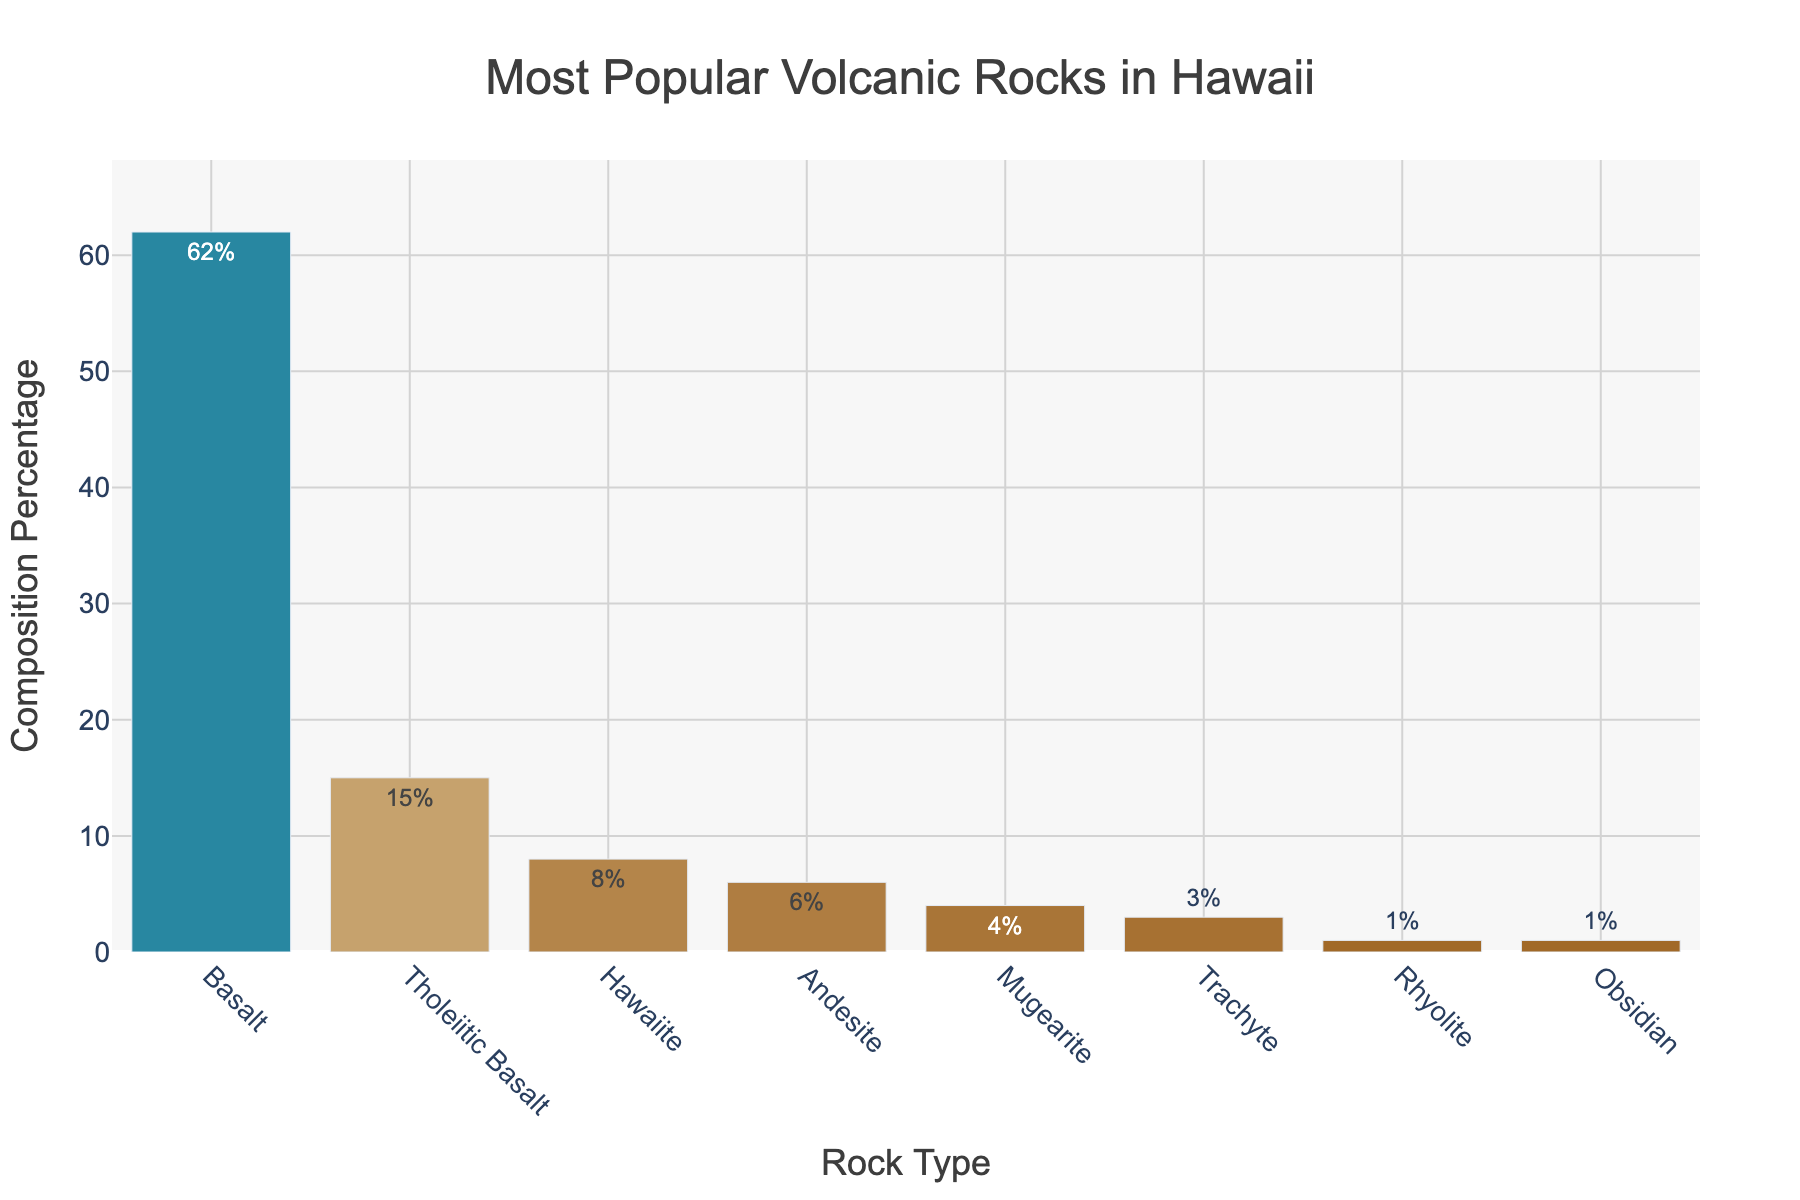Which volcanic rock type has the highest composition percentage? The rock type with the highest composition percentage has the tallest bar in the chart. Basalt has the tallest bar indicating it has the highest composition percentage.
Answer: Basalt What's the combined composition percentage of Trachyte, Rhyolite, and Obsidian? Add the composition percentages of Trachyte (3%), Rhyolite (1%), and Obsidian (1%). 3 + 1 + 1 = 5.
Answer: 5% Which rock type has a composition percentage 7% higher than Andesite? Andesite has a composition percentage of 6%. Adding 7% gives 13%, which corresponds to Tholeiitic Basalt (15%) as the nearest higher percentage.
Answer: Tholeiitic Basalt Is the sum of the composition percentages for Hawaiite and Mugearite greater than the percentage for Tholeiitic Basalt? Hawaiite has 8% and Mugearite has 4%, so the sum is 8% + 4% = 12%. Tholeiitic Basalt is 15%. 12% is less than 15%, so no.
Answer: No What's the composition percentage difference between Basalt and Tholeiitic Basalt? Subtract Tholeiitic Basalt's percentage (15%) from Basalt's percentage (62%). 62 - 15 = 47.
Answer: 47% Which rock types have a composition percentage of 1%? Identify the rock types with bars labeled as 1%. Rhyolite and Obsidian each have a composition percentage of 1%.
Answer: Rhyolite and Obsidian How much taller is the bar for Hawaiite compared to Andesite? Subtract Andesite's composition percentage (6%) from Hawaiite's percentage (8%). 8 - 6 = 2.
Answer: 2% What is the average composition percentage of the top three rock types? Sum the composition percentages of Basalt, Tholeiitic Basalt, and Hawaiite which are the top three rock types (62%, 15%, and 8%), then divide by 3. (62 + 15 + 8) / 3 = 85 / 3 ≈ 28.33.
Answer: 28.33% 